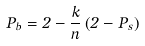Convert formula to latex. <formula><loc_0><loc_0><loc_500><loc_500>P _ { b } = 2 - \frac { k } { n } \left ( 2 - P _ { s } \right )</formula> 